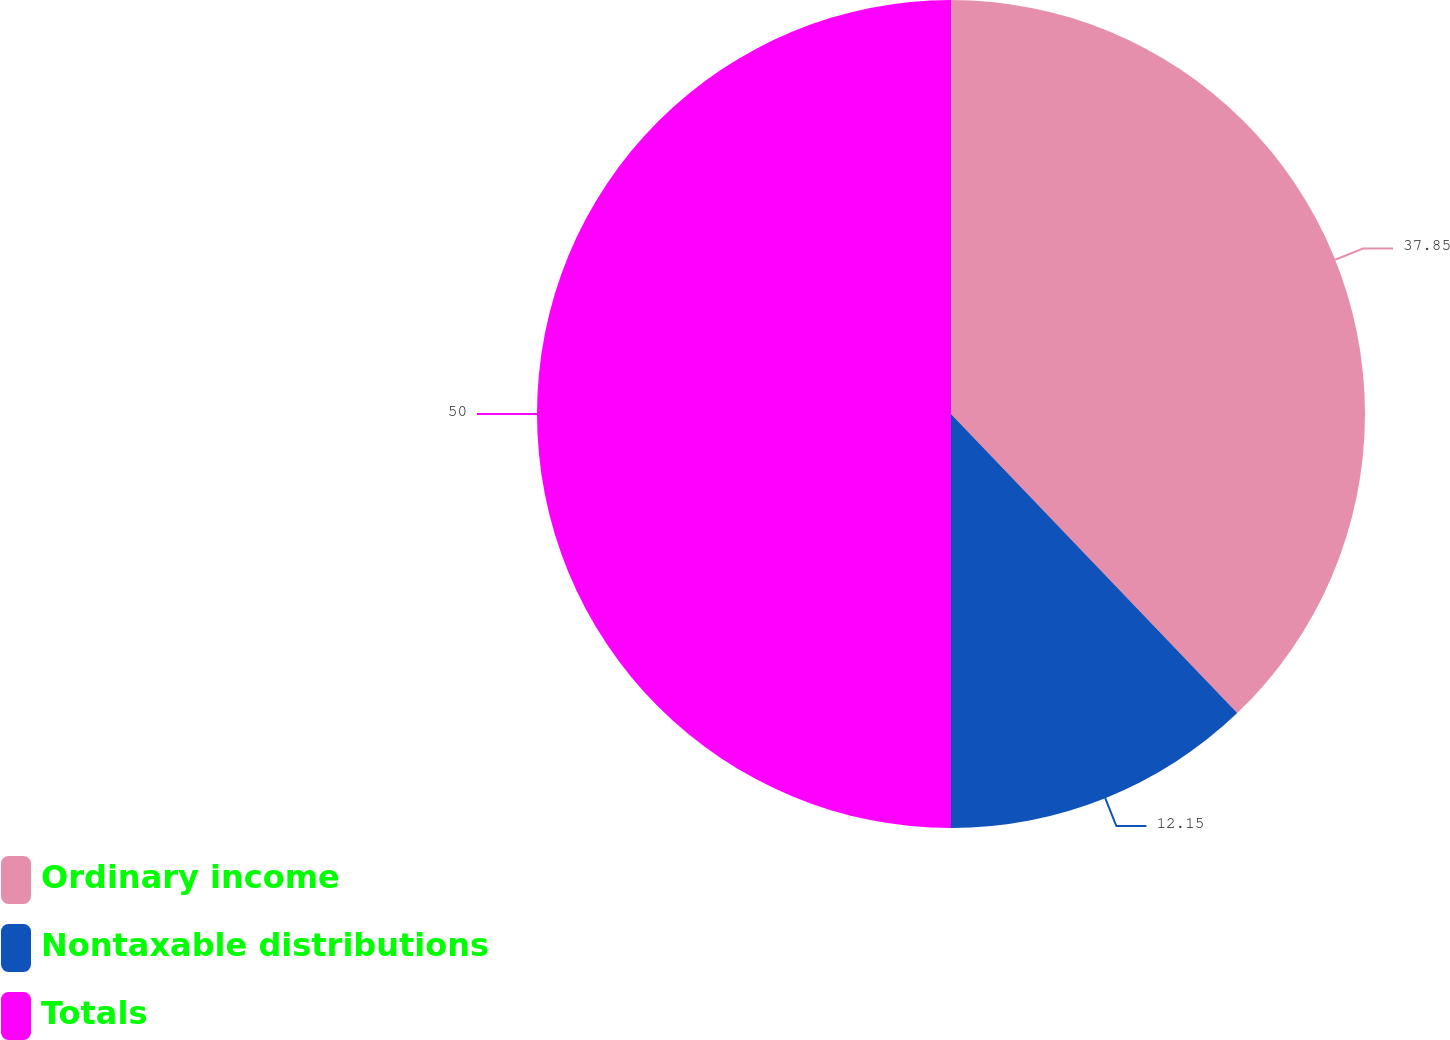<chart> <loc_0><loc_0><loc_500><loc_500><pie_chart><fcel>Ordinary income<fcel>Nontaxable distributions<fcel>Totals<nl><fcel>37.85%<fcel>12.15%<fcel>50.0%<nl></chart> 